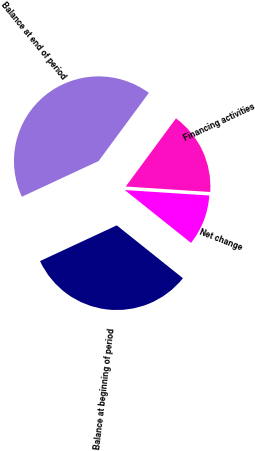<chart> <loc_0><loc_0><loc_500><loc_500><pie_chart><fcel>Financing activities<fcel>Net change<fcel>Balance at beginning of period<fcel>Balance at end of period<nl><fcel>15.92%<fcel>9.7%<fcel>32.34%<fcel>42.04%<nl></chart> 